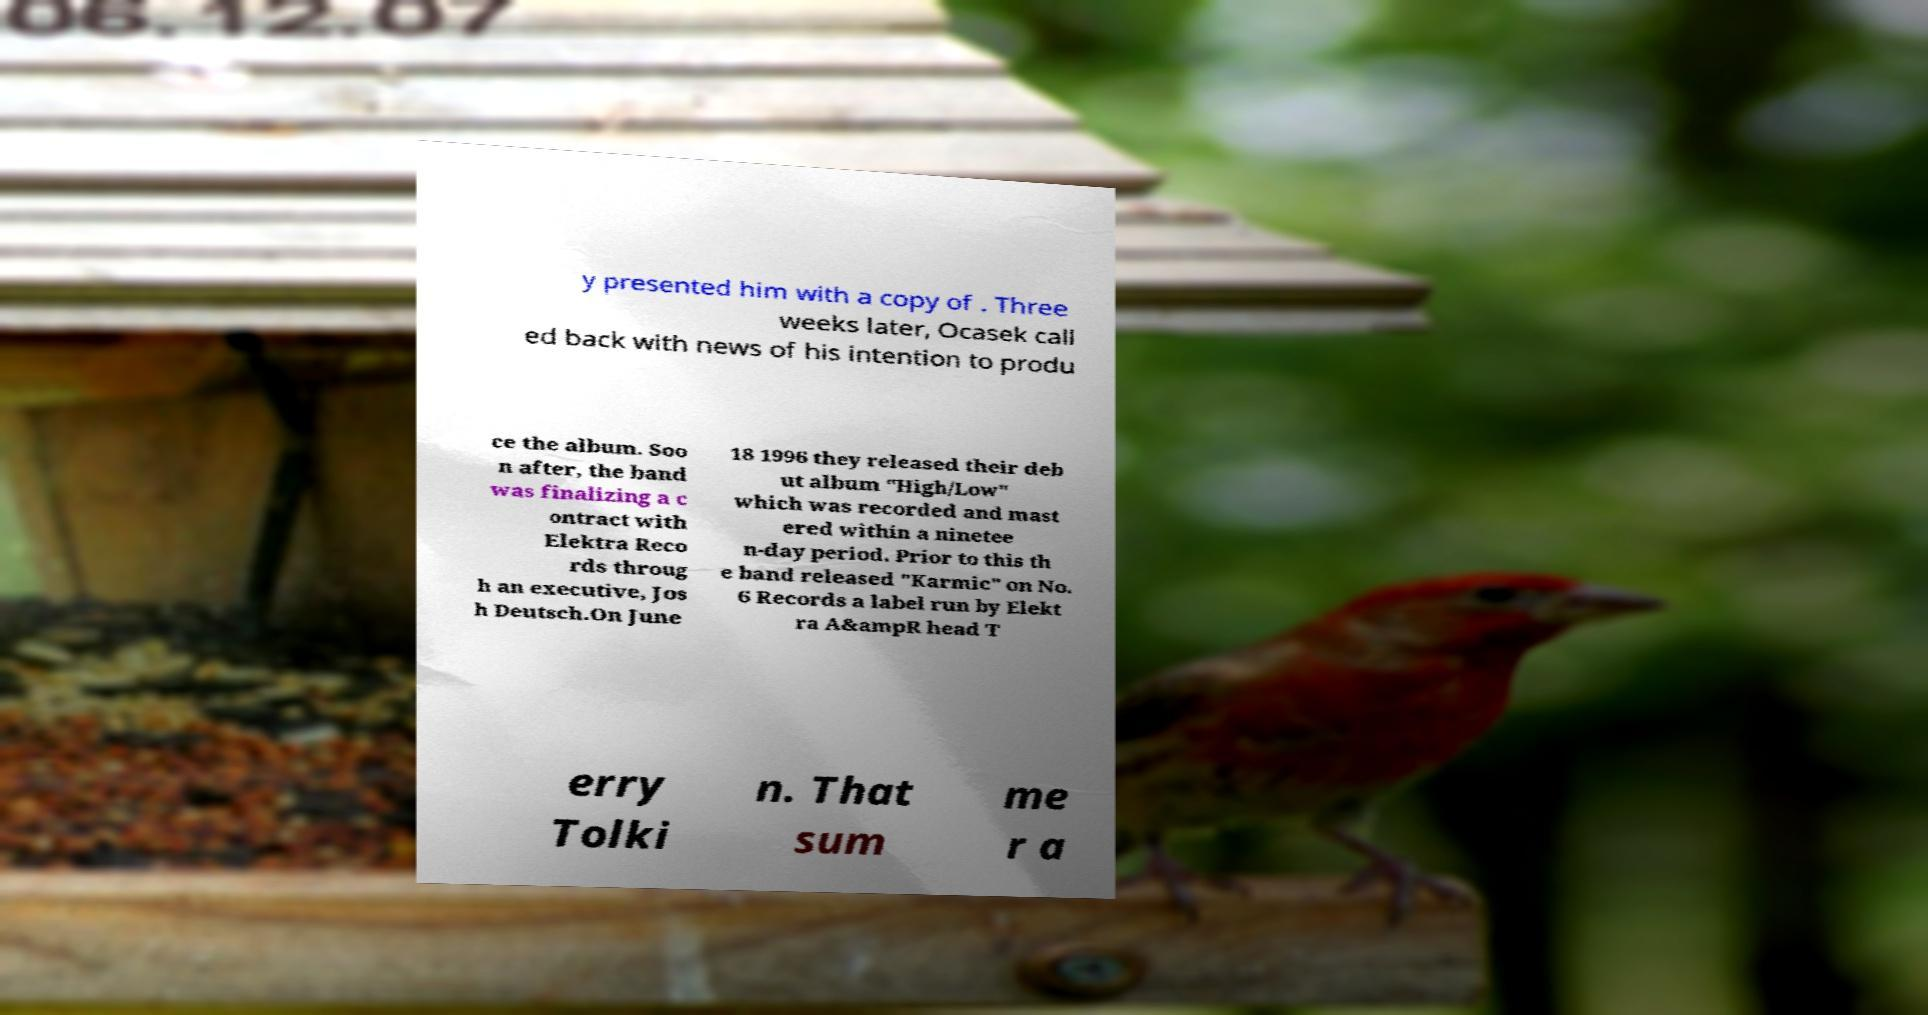Can you accurately transcribe the text from the provided image for me? y presented him with a copy of . Three weeks later, Ocasek call ed back with news of his intention to produ ce the album. Soo n after, the band was finalizing a c ontract with Elektra Reco rds throug h an executive, Jos h Deutsch.On June 18 1996 they released their deb ut album "High/Low" which was recorded and mast ered within a ninetee n-day period. Prior to this th e band released "Karmic" on No. 6 Records a label run by Elekt ra A&ampR head T erry Tolki n. That sum me r a 